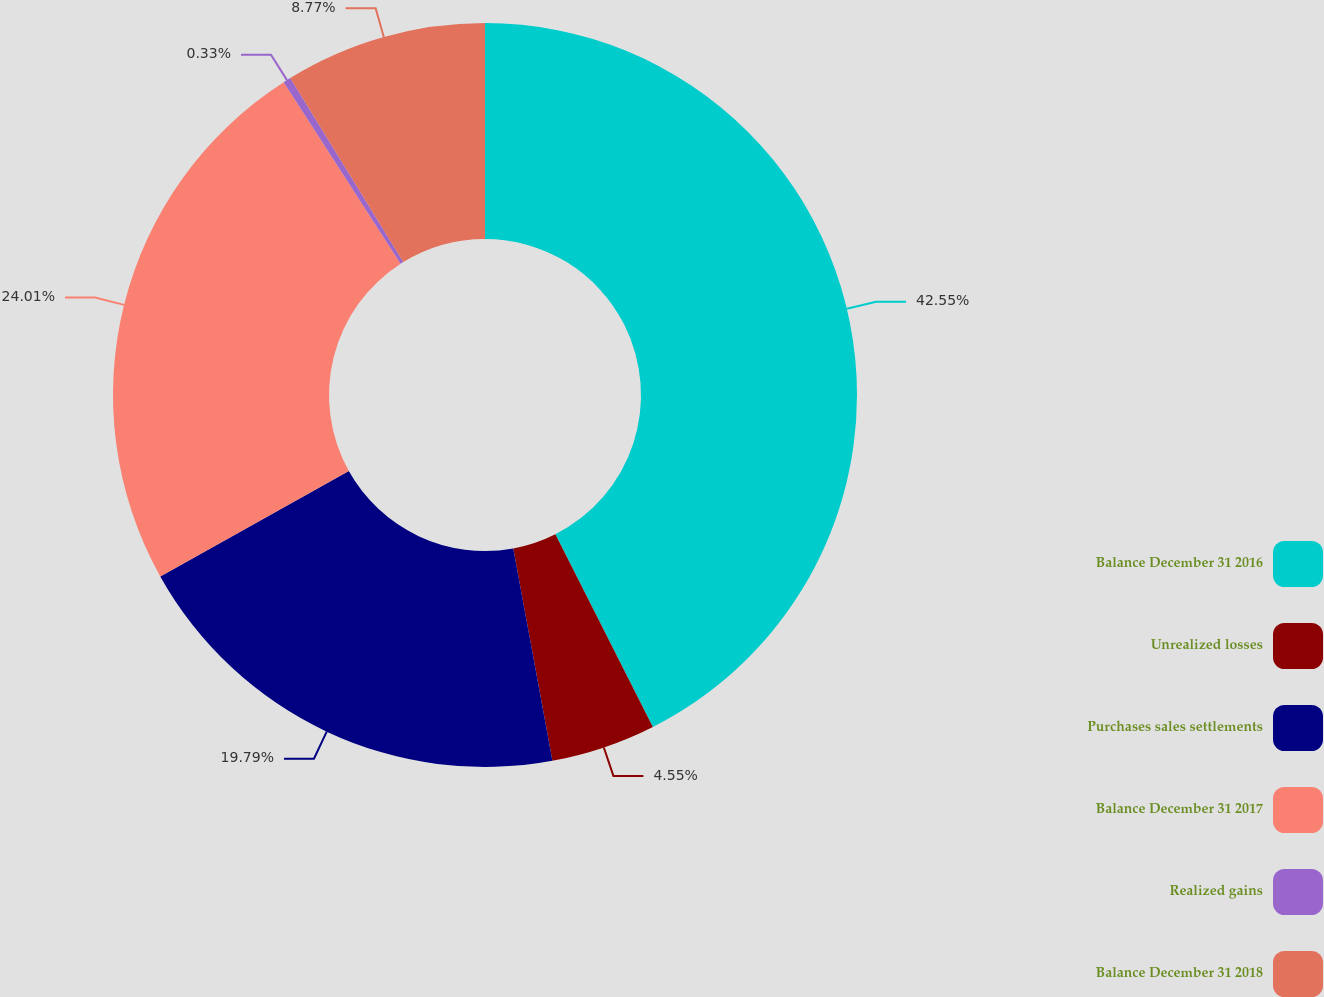<chart> <loc_0><loc_0><loc_500><loc_500><pie_chart><fcel>Balance December 31 2016<fcel>Unrealized losses<fcel>Purchases sales settlements<fcel>Balance December 31 2017<fcel>Realized gains<fcel>Balance December 31 2018<nl><fcel>42.55%<fcel>4.55%<fcel>19.79%<fcel>24.01%<fcel>0.33%<fcel>8.77%<nl></chart> 